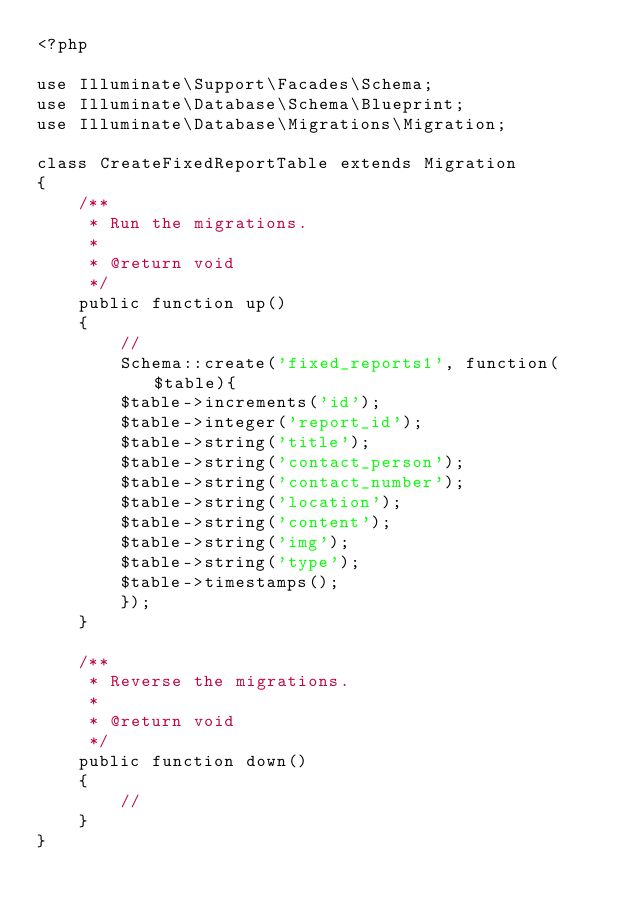<code> <loc_0><loc_0><loc_500><loc_500><_PHP_><?php

use Illuminate\Support\Facades\Schema;
use Illuminate\Database\Schema\Blueprint;
use Illuminate\Database\Migrations\Migration;

class CreateFixedReportTable extends Migration
{
    /**
     * Run the migrations.
     *
     * @return void
     */
    public function up()
    {
        //
        Schema::create('fixed_reports1', function($table){
        $table->increments('id');
        $table->integer('report_id');
        $table->string('title');
        $table->string('contact_person');
        $table->string('contact_number');
        $table->string('location');
        $table->string('content');
        $table->string('img');
        $table->string('type');
        $table->timestamps();
        });
    }

    /**
     * Reverse the migrations.
     *
     * @return void
     */
    public function down()
    {
        //
    }
}
</code> 